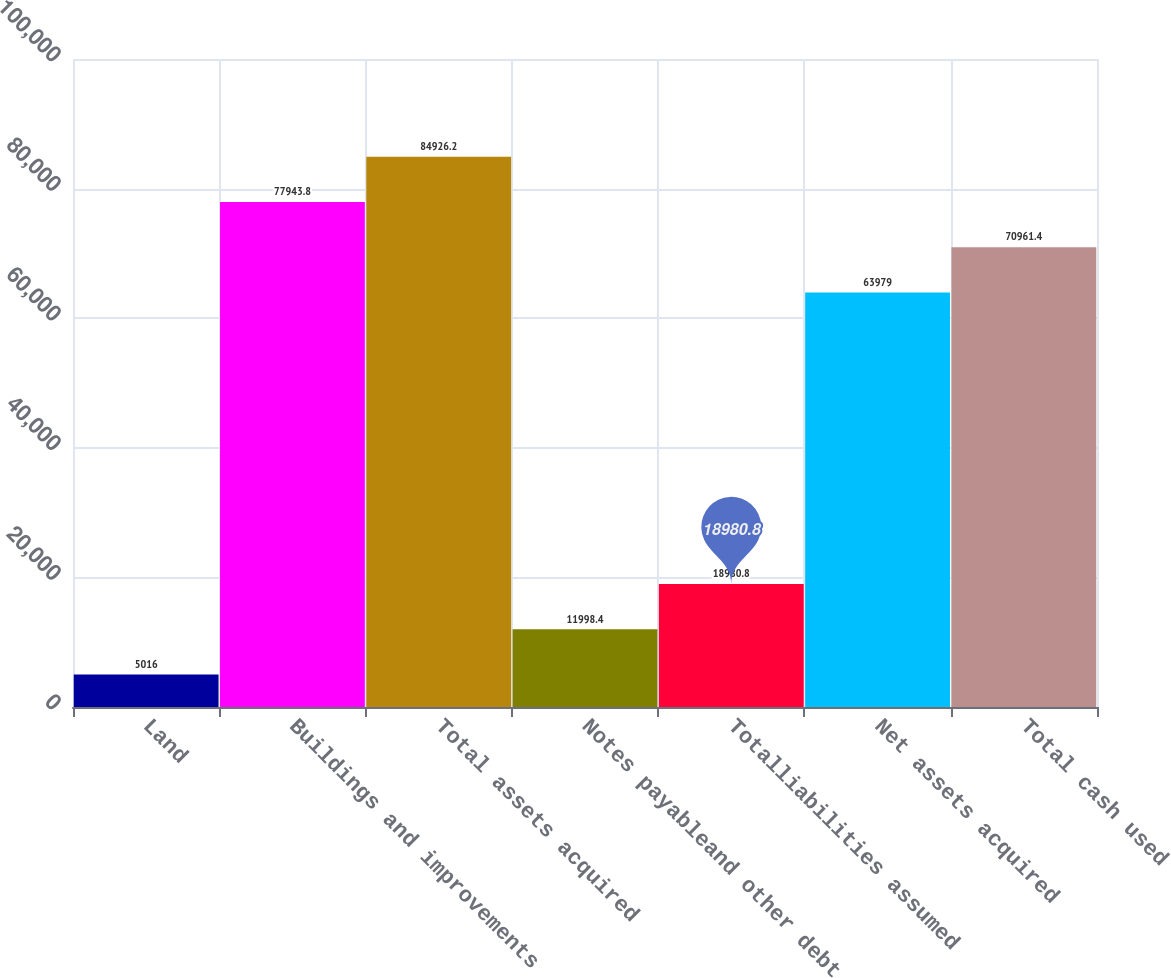Convert chart to OTSL. <chart><loc_0><loc_0><loc_500><loc_500><bar_chart><fcel>Land<fcel>Buildings and improvements<fcel>Total assets acquired<fcel>Notes payableand other debt<fcel>Totalliabilities assumed<fcel>Net assets acquired<fcel>Total cash used<nl><fcel>5016<fcel>77943.8<fcel>84926.2<fcel>11998.4<fcel>18980.8<fcel>63979<fcel>70961.4<nl></chart> 